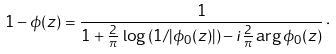Convert formula to latex. <formula><loc_0><loc_0><loc_500><loc_500>1 - \phi ( z ) = \frac { 1 } { 1 + \frac { 2 } { \pi } \, \log \left ( 1 / | \phi _ { 0 } ( z ) | \right ) - i \frac { 2 } { \pi } \arg \phi _ { 0 } ( z ) } \, \cdot</formula> 